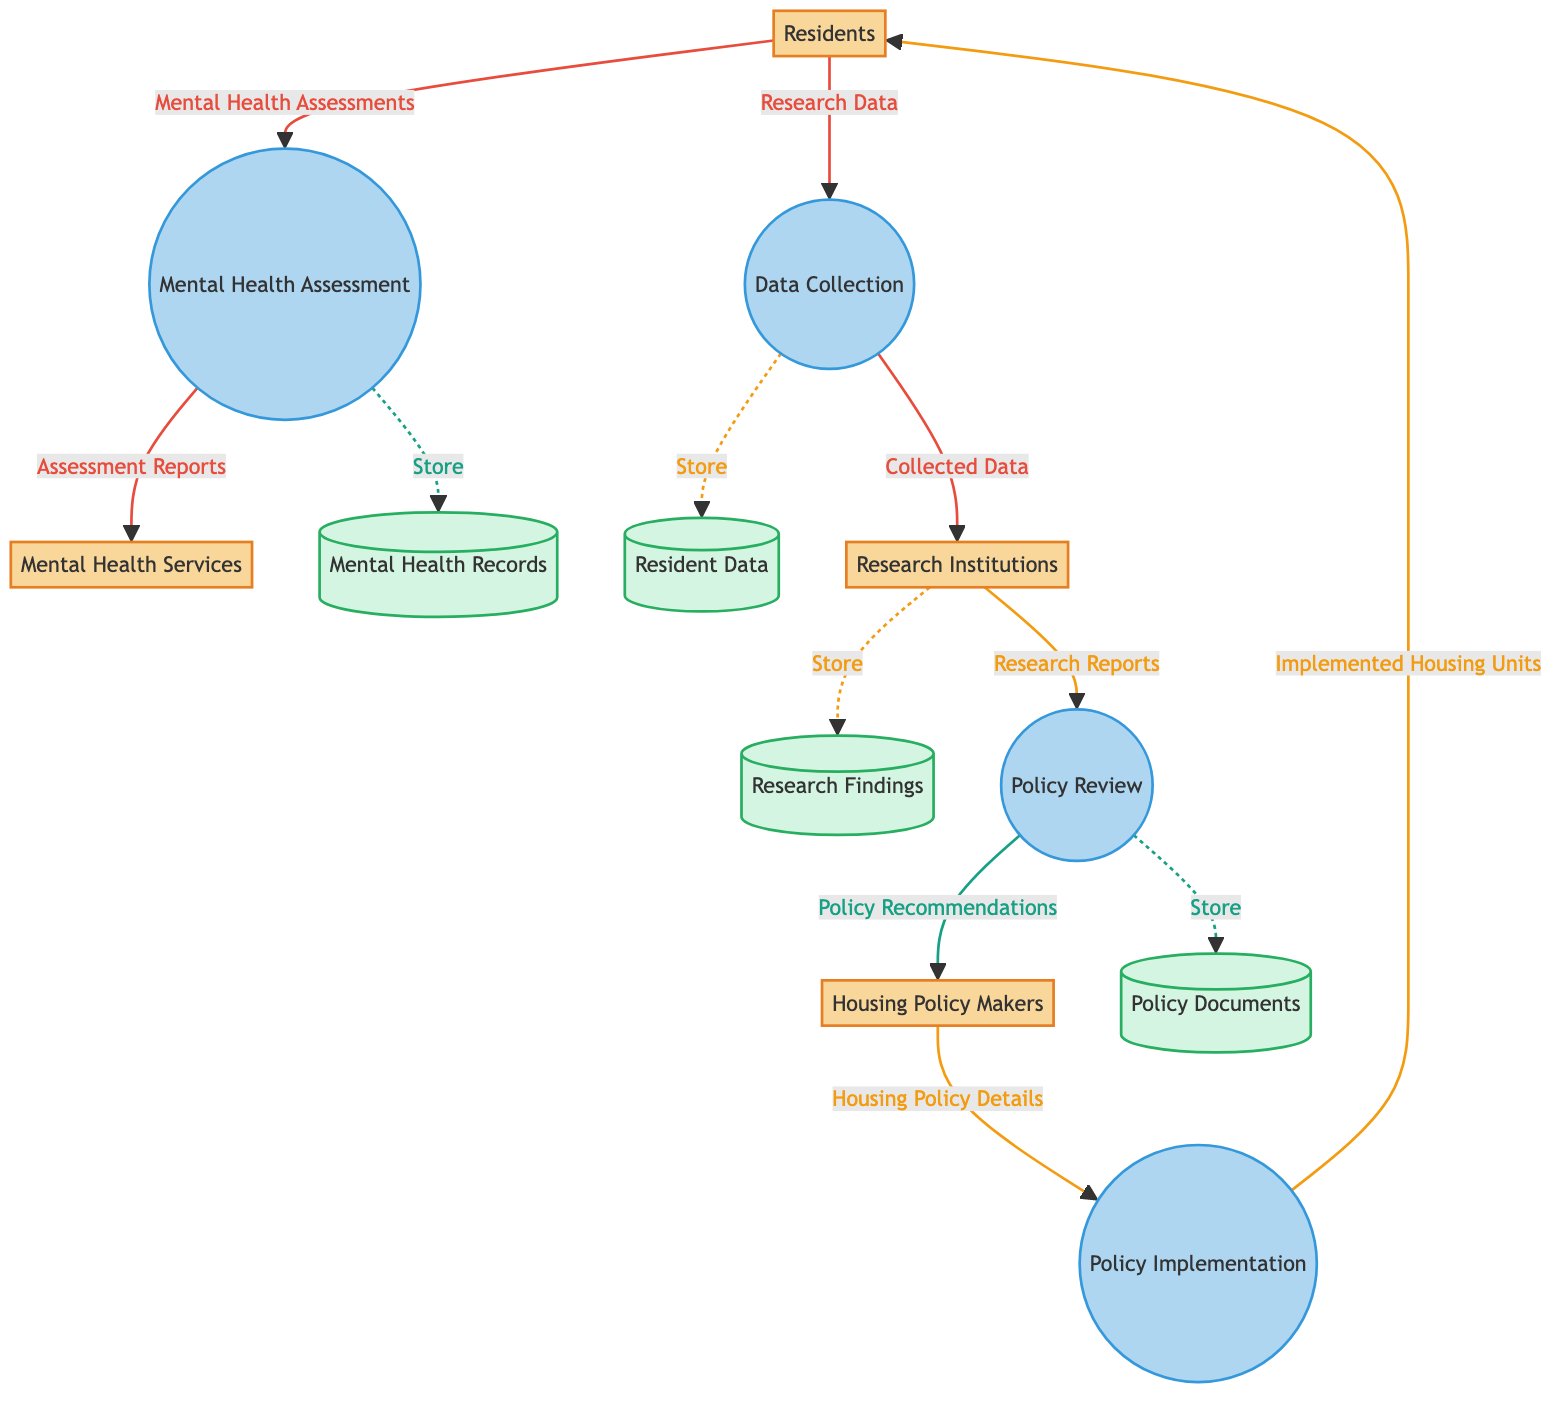What are the inputs to the Policy Implementation process? The inputs listed in the diagram for the Policy Implementation process are provided by the Housing Policy Makers.
Answer: Housing Policy Makers How many main entities are present in the diagram? By counting the distinct entities represented in the diagram, we find there are four main entities: Residents, Housing Policy Makers, Mental Health Services, and Research Institutions.
Answer: 4 What is the output of Mental Health Assessment? The output from the Mental Health Assessment process is the Assessment Reports that are sent to Mental Health Services.
Answer: Assessment Reports Which entity receives the Research Data? The Data Collection process takes input from Residents and the output of this process, which is the Research Data, goes to the Research Institutions.
Answer: Research Institutions What process involves the analysis and modification of housing policies? The Policy Review process is responsible for the analysis and modification based on research data gathered from Research Institutions.
Answer: Policy Review What database stores mental health assessment records? The Mental Health Records database is specifically designated for storing the records of mental health assessments conducted by the Mental Health Assessment process.
Answer: Mental Health Records Which node produces the Policy Recommendations? The Policy Review process produces Policy Recommendations that are directed back to the Housing Policy Makers as outputs.
Answer: Policy Review How does the Data Collection process relate to the Residents? The Data Collection process gathers data from the Residents, which serves as input into the process leading to the collected data going to Research Institutions.
Answer: Input to Data Collection What type of data is stored in the Research Findings repository? The Research Findings repository stores the collected data from the Data Collection process resulting from research conducted by research institutions on residents' mental health.
Answer: Research data and findings 